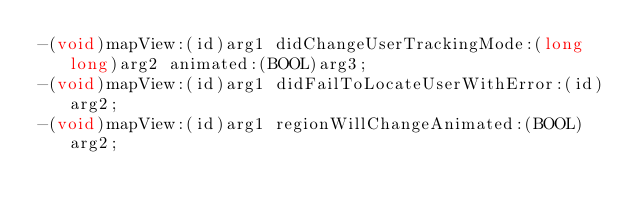Convert code to text. <code><loc_0><loc_0><loc_500><loc_500><_C_>-(void)mapView:(id)arg1 didChangeUserTrackingMode:(long long)arg2 animated:(BOOL)arg3;
-(void)mapView:(id)arg1 didFailToLocateUserWithError:(id)arg2;
-(void)mapView:(id)arg1 regionWillChangeAnimated:(BOOL)arg2;</code> 